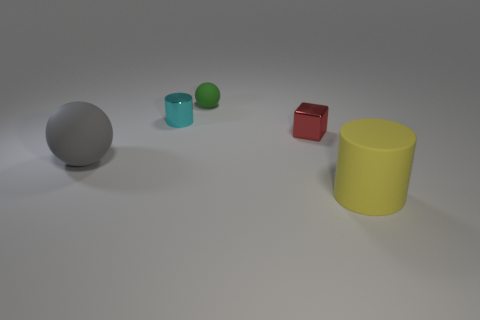How many other things are there of the same color as the small matte ball?
Your response must be concise. 0. What number of other things are there of the same shape as the big gray rubber thing?
Your answer should be compact. 1. Is the shape of the rubber object right of the cube the same as the matte thing behind the large rubber ball?
Make the answer very short. No. Is the number of red metallic things on the left side of the red block the same as the number of gray things in front of the gray object?
Make the answer very short. Yes. The big rubber object that is to the right of the big rubber object that is to the left of the cylinder to the right of the tiny cyan shiny thing is what shape?
Provide a succinct answer. Cylinder. Are the big thing behind the yellow thing and the cylinder that is behind the large rubber cylinder made of the same material?
Make the answer very short. No. The small metallic thing that is behind the red metal thing has what shape?
Make the answer very short. Cylinder. Are there fewer tiny cyan metallic things than tiny red matte objects?
Make the answer very short. No. There is a large object that is behind the cylinder in front of the big gray matte ball; is there a sphere that is to the left of it?
Offer a very short reply. No. How many rubber things are tiny balls or small things?
Offer a terse response. 1. 